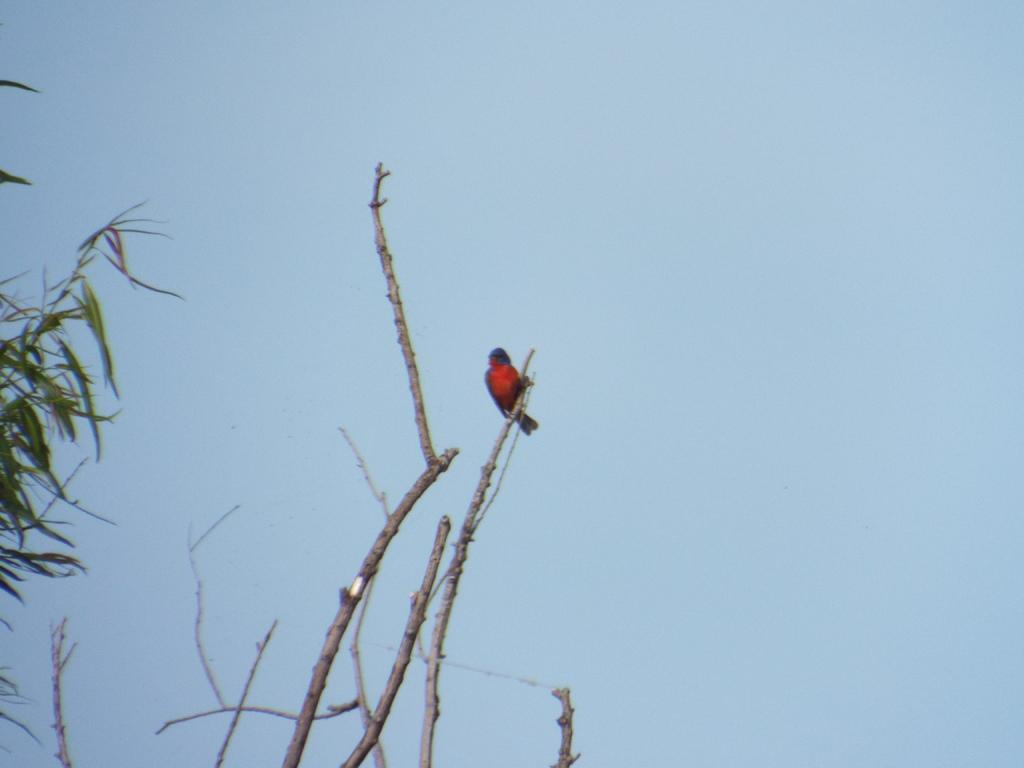What type of animal is in the image? There is a bird in the image. What color is the bird? The bird is red in color. Where is the bird located in the image? The bird is on a tree. What can be seen on the left side of the image? There is a tree on the left side of the image. What is visible in the background of the image? The sky is visible in the background of the image. What color is the sky? The sky is blue in color. What type of plough is being used by the bird in the image? There is no plough present in the image; it features a red bird on a tree. What type of iron is visible in the image? There is no iron present in the image. 